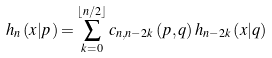Convert formula to latex. <formula><loc_0><loc_0><loc_500><loc_500>h _ { n } \left ( x | p \right ) = \sum _ { k = 0 } ^ { \left \lfloor n / 2 \right \rfloor } c _ { n , n - 2 k } \left ( p , q \right ) h _ { n - 2 k } \left ( x | q \right )</formula> 